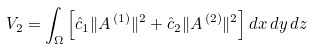Convert formula to latex. <formula><loc_0><loc_0><loc_500><loc_500>V _ { 2 } = \int _ { \Omega } \left [ \hat { c } _ { 1 } \| { A } ^ { \, ( 1 ) } \| ^ { 2 } + \hat { c } _ { 2 } \| { A } ^ { \, ( 2 ) } \| ^ { 2 } \right ] d x \, d y \, d z</formula> 